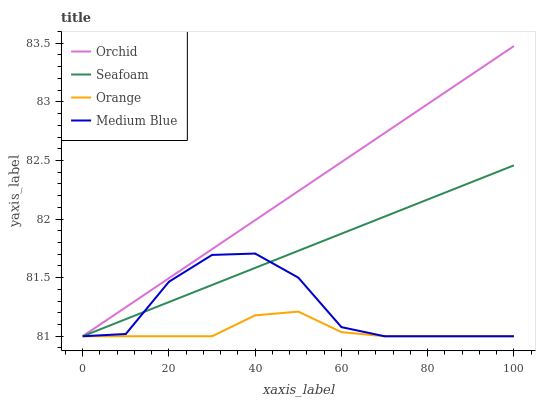Does Orange have the minimum area under the curve?
Answer yes or no. Yes. Does Orchid have the maximum area under the curve?
Answer yes or no. Yes. Does Medium Blue have the minimum area under the curve?
Answer yes or no. No. Does Medium Blue have the maximum area under the curve?
Answer yes or no. No. Is Orchid the smoothest?
Answer yes or no. Yes. Is Medium Blue the roughest?
Answer yes or no. Yes. Is Seafoam the smoothest?
Answer yes or no. No. Is Seafoam the roughest?
Answer yes or no. No. Does Orchid have the highest value?
Answer yes or no. Yes. Does Medium Blue have the highest value?
Answer yes or no. No. Does Orchid intersect Medium Blue?
Answer yes or no. Yes. Is Orchid less than Medium Blue?
Answer yes or no. No. Is Orchid greater than Medium Blue?
Answer yes or no. No. 